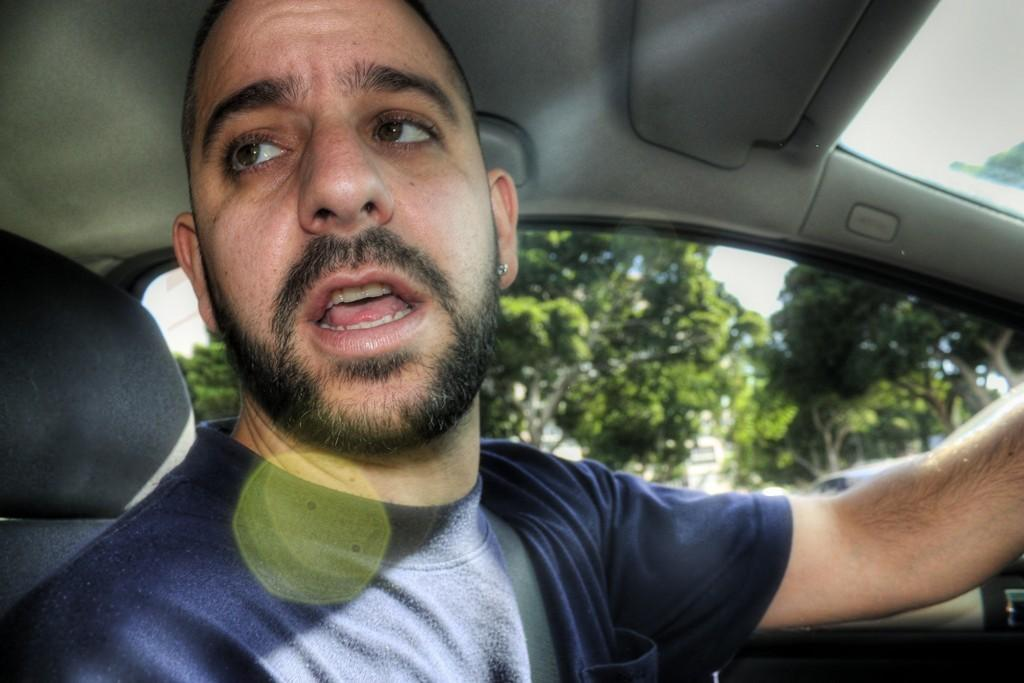What is the setting of the image? The image is taken inside a vehicle. Who is present in the vehicle? There is a man in the vehicle. What is the man wearing? The man is wearing a blue shirt. What is the man doing in the image? The man's mouth is open, suggesting he is talking. What can be seen in the background of the image? There are trees in the background of the image. How would you describe the weather based on the image? The sky is clear and sunny. What type of soda is the man holding in the image? There is no soda present in the image. What is the man rubbing on the trees in the background? There is no indication of the man rubbing anything on the trees in the background, as he is inside the vehicle and focused on talking. 